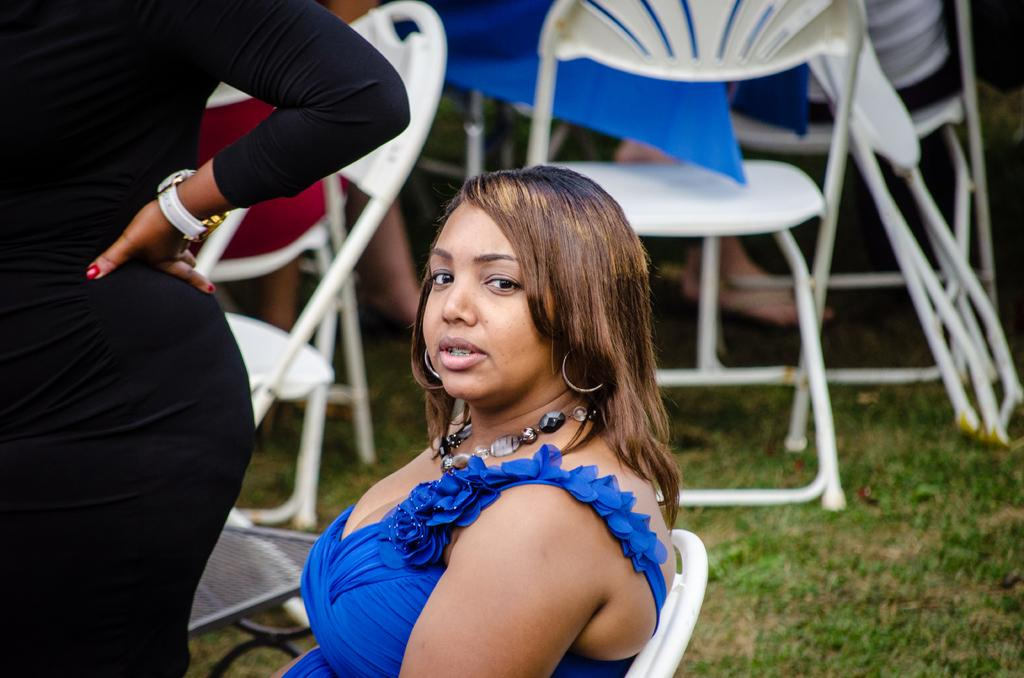Who is the main subject in the image? There is a woman in the image. What is the woman doing in the image? The woman is sitting on a chair. Can you describe the background of the image? There are people in the background of the image, and there are chairs on the grass. the grass. What type of cheese is being sprinkled on the woman's head in the image? There is no cheese present in the image, and the woman's head is not being sprinkled with any substance. 